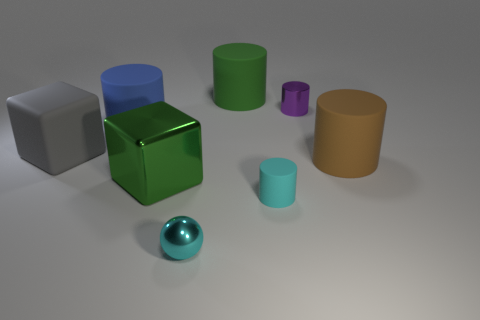What number of other objects are the same material as the small ball?
Your answer should be very brief. 2. The big cube that is made of the same material as the cyan cylinder is what color?
Make the answer very short. Gray. How many brown objects are the same material as the tiny purple cylinder?
Offer a very short reply. 0. There is a green matte cylinder behind the small cyan rubber thing; is its size the same as the cube that is behind the big green shiny block?
Ensure brevity in your answer.  Yes. What material is the cylinder that is on the left side of the block that is in front of the big brown matte cylinder?
Your answer should be very brief. Rubber. Are there fewer big cylinders that are behind the large blue cylinder than big matte objects that are behind the brown cylinder?
Your answer should be very brief. Yes. What material is the small thing that is the same color as the tiny ball?
Provide a succinct answer. Rubber. Is there anything else that has the same shape as the small cyan metal thing?
Keep it short and to the point. No. What is the big block in front of the big gray cube made of?
Keep it short and to the point. Metal. There is a tiny metal sphere; are there any large cylinders to the left of it?
Your answer should be very brief. Yes. 